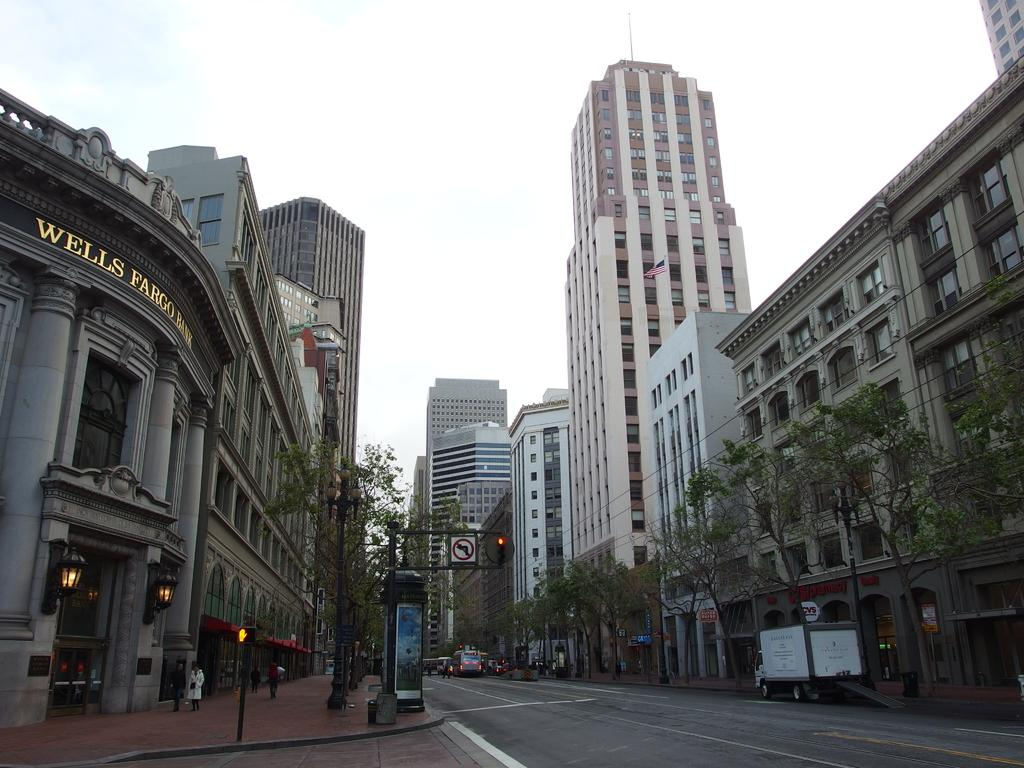What type of structures can be seen in the image? There are buildings in the image. What else can be seen in the image besides buildings? There are trees, people walking on the sidewalk, vehicles on the road, and a cloudy sky in the image. What type of wool is being used by the manager to make a payment in the image? There is no wool, manager, or payment present in the image. 